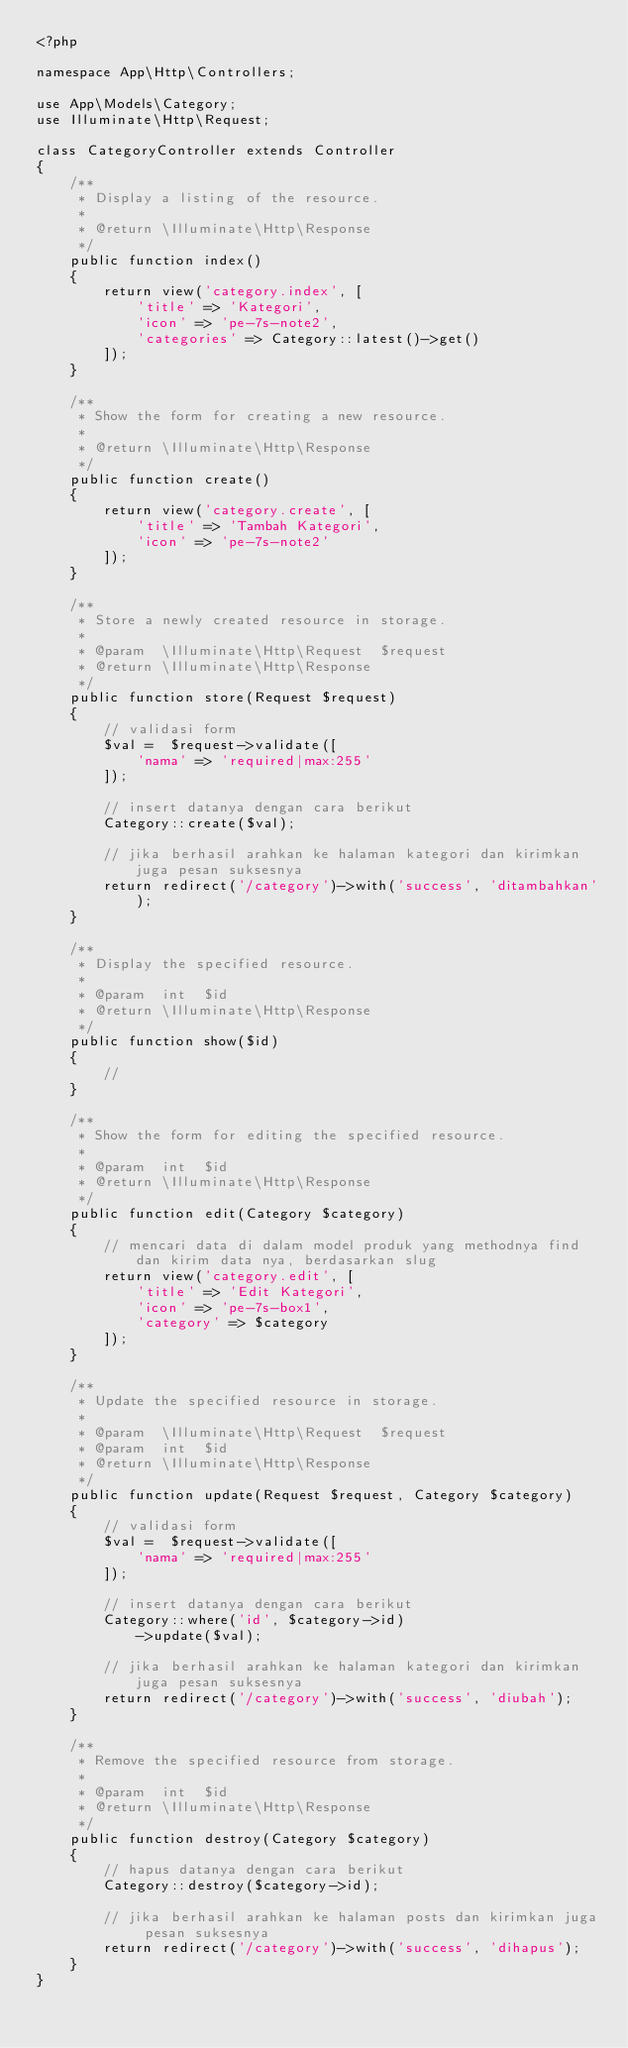<code> <loc_0><loc_0><loc_500><loc_500><_PHP_><?php

namespace App\Http\Controllers;

use App\Models\Category;
use Illuminate\Http\Request;

class CategoryController extends Controller
{
    /**
     * Display a listing of the resource.
     *
     * @return \Illuminate\Http\Response
     */
    public function index()
    {
        return view('category.index', [
            'title' => 'Kategori',
            'icon' => 'pe-7s-note2',
            'categories' => Category::latest()->get()
        ]);
    }

    /**
     * Show the form for creating a new resource.
     *
     * @return \Illuminate\Http\Response
     */
    public function create()
    {
        return view('category.create', [
            'title' => 'Tambah Kategori',
            'icon' => 'pe-7s-note2'
        ]);
    }

    /**
     * Store a newly created resource in storage.
     *
     * @param  \Illuminate\Http\Request  $request
     * @return \Illuminate\Http\Response
     */
    public function store(Request $request)
    {
        // validasi form
        $val =  $request->validate([
            'nama' => 'required|max:255'
        ]);

        // insert datanya dengan cara berikut
        Category::create($val);

        // jika berhasil arahkan ke halaman kategori dan kirimkan juga pesan suksesnya
        return redirect('/category')->with('success', 'ditambahkan');
    }

    /**
     * Display the specified resource.
     *
     * @param  int  $id
     * @return \Illuminate\Http\Response
     */
    public function show($id)
    {
        // 
    }

    /**
     * Show the form for editing the specified resource.
     *
     * @param  int  $id
     * @return \Illuminate\Http\Response
     */
    public function edit(Category $category)
    {
        // mencari data di dalam model produk yang methodnya find dan kirim data nya, berdasarkan slug
        return view('category.edit', [
            'title' => 'Edit Kategori',
            'icon' => 'pe-7s-box1',
            'category' => $category
        ]);
    }

    /**
     * Update the specified resource in storage.
     *
     * @param  \Illuminate\Http\Request  $request
     * @param  int  $id
     * @return \Illuminate\Http\Response
     */
    public function update(Request $request, Category $category)
    {
        // validasi form
        $val =  $request->validate([
            'nama' => 'required|max:255'
        ]);

        // insert datanya dengan cara berikut
        Category::where('id', $category->id)
            ->update($val);

        // jika berhasil arahkan ke halaman kategori dan kirimkan juga pesan suksesnya
        return redirect('/category')->with('success', 'diubah');
    }

    /**
     * Remove the specified resource from storage.
     *
     * @param  int  $id
     * @return \Illuminate\Http\Response
     */
    public function destroy(Category $category)
    {
        // hapus datanya dengan cara berikut
        Category::destroy($category->id);

        // jika berhasil arahkan ke halaman posts dan kirimkan juga pesan suksesnya
        return redirect('/category')->with('success', 'dihapus');
    }
}
</code> 